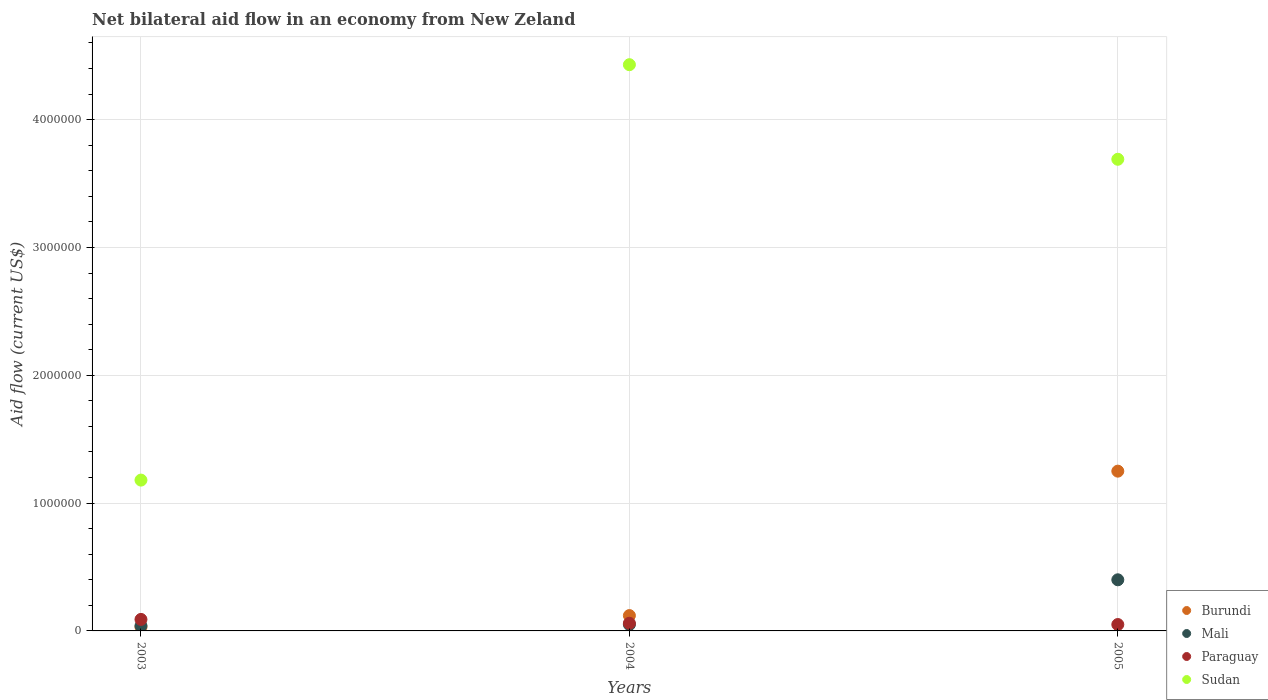Across all years, what is the maximum net bilateral aid flow in Burundi?
Offer a very short reply. 1.25e+06. In which year was the net bilateral aid flow in Burundi maximum?
Ensure brevity in your answer.  2005. What is the total net bilateral aid flow in Burundi in the graph?
Make the answer very short. 1.40e+06. What is the difference between the net bilateral aid flow in Sudan in 2003 and that in 2005?
Your answer should be very brief. -2.51e+06. What is the difference between the net bilateral aid flow in Mali in 2004 and the net bilateral aid flow in Burundi in 2005?
Your response must be concise. -1.20e+06. What is the average net bilateral aid flow in Burundi per year?
Give a very brief answer. 4.67e+05. In the year 2003, what is the difference between the net bilateral aid flow in Sudan and net bilateral aid flow in Paraguay?
Provide a succinct answer. 1.09e+06. What is the ratio of the net bilateral aid flow in Paraguay in 2003 to that in 2005?
Ensure brevity in your answer.  1.8. Is the net bilateral aid flow in Paraguay in 2004 less than that in 2005?
Your answer should be very brief. No. Is the difference between the net bilateral aid flow in Sudan in 2004 and 2005 greater than the difference between the net bilateral aid flow in Paraguay in 2004 and 2005?
Provide a succinct answer. Yes. What is the difference between the highest and the second highest net bilateral aid flow in Burundi?
Keep it short and to the point. 1.13e+06. What is the difference between the highest and the lowest net bilateral aid flow in Sudan?
Make the answer very short. 3.25e+06. In how many years, is the net bilateral aid flow in Burundi greater than the average net bilateral aid flow in Burundi taken over all years?
Give a very brief answer. 1. Is the sum of the net bilateral aid flow in Sudan in 2003 and 2005 greater than the maximum net bilateral aid flow in Mali across all years?
Offer a very short reply. Yes. Is it the case that in every year, the sum of the net bilateral aid flow in Mali and net bilateral aid flow in Paraguay  is greater than the sum of net bilateral aid flow in Sudan and net bilateral aid flow in Burundi?
Offer a very short reply. No. Is it the case that in every year, the sum of the net bilateral aid flow in Sudan and net bilateral aid flow in Burundi  is greater than the net bilateral aid flow in Mali?
Make the answer very short. Yes. Does the net bilateral aid flow in Paraguay monotonically increase over the years?
Provide a short and direct response. No. Is the net bilateral aid flow in Paraguay strictly greater than the net bilateral aid flow in Mali over the years?
Keep it short and to the point. No. How many dotlines are there?
Keep it short and to the point. 4. Are the values on the major ticks of Y-axis written in scientific E-notation?
Your answer should be very brief. No. Does the graph contain any zero values?
Your response must be concise. No. Does the graph contain grids?
Provide a succinct answer. Yes. Where does the legend appear in the graph?
Provide a short and direct response. Bottom right. How many legend labels are there?
Ensure brevity in your answer.  4. How are the legend labels stacked?
Offer a very short reply. Vertical. What is the title of the graph?
Your response must be concise. Net bilateral aid flow in an economy from New Zeland. Does "Latin America(all income levels)" appear as one of the legend labels in the graph?
Your response must be concise. No. What is the label or title of the X-axis?
Your response must be concise. Years. What is the Aid flow (current US$) in Burundi in 2003?
Your response must be concise. 3.00e+04. What is the Aid flow (current US$) of Mali in 2003?
Provide a succinct answer. 4.00e+04. What is the Aid flow (current US$) in Paraguay in 2003?
Provide a short and direct response. 9.00e+04. What is the Aid flow (current US$) of Sudan in 2003?
Keep it short and to the point. 1.18e+06. What is the Aid flow (current US$) of Sudan in 2004?
Offer a very short reply. 4.43e+06. What is the Aid flow (current US$) in Burundi in 2005?
Make the answer very short. 1.25e+06. What is the Aid flow (current US$) of Mali in 2005?
Your answer should be compact. 4.00e+05. What is the Aid flow (current US$) of Paraguay in 2005?
Your answer should be very brief. 5.00e+04. What is the Aid flow (current US$) of Sudan in 2005?
Give a very brief answer. 3.69e+06. Across all years, what is the maximum Aid flow (current US$) in Burundi?
Your answer should be compact. 1.25e+06. Across all years, what is the maximum Aid flow (current US$) of Sudan?
Your answer should be compact. 4.43e+06. Across all years, what is the minimum Aid flow (current US$) of Burundi?
Provide a short and direct response. 3.00e+04. Across all years, what is the minimum Aid flow (current US$) of Paraguay?
Keep it short and to the point. 5.00e+04. Across all years, what is the minimum Aid flow (current US$) in Sudan?
Ensure brevity in your answer.  1.18e+06. What is the total Aid flow (current US$) of Burundi in the graph?
Your answer should be very brief. 1.40e+06. What is the total Aid flow (current US$) in Mali in the graph?
Provide a short and direct response. 4.90e+05. What is the total Aid flow (current US$) of Sudan in the graph?
Provide a succinct answer. 9.30e+06. What is the difference between the Aid flow (current US$) of Burundi in 2003 and that in 2004?
Provide a short and direct response. -9.00e+04. What is the difference between the Aid flow (current US$) in Paraguay in 2003 and that in 2004?
Your response must be concise. 3.00e+04. What is the difference between the Aid flow (current US$) of Sudan in 2003 and that in 2004?
Provide a short and direct response. -3.25e+06. What is the difference between the Aid flow (current US$) in Burundi in 2003 and that in 2005?
Your response must be concise. -1.22e+06. What is the difference between the Aid flow (current US$) in Mali in 2003 and that in 2005?
Make the answer very short. -3.60e+05. What is the difference between the Aid flow (current US$) in Sudan in 2003 and that in 2005?
Provide a succinct answer. -2.51e+06. What is the difference between the Aid flow (current US$) in Burundi in 2004 and that in 2005?
Offer a terse response. -1.13e+06. What is the difference between the Aid flow (current US$) in Mali in 2004 and that in 2005?
Your answer should be compact. -3.50e+05. What is the difference between the Aid flow (current US$) in Sudan in 2004 and that in 2005?
Give a very brief answer. 7.40e+05. What is the difference between the Aid flow (current US$) in Burundi in 2003 and the Aid flow (current US$) in Mali in 2004?
Provide a succinct answer. -2.00e+04. What is the difference between the Aid flow (current US$) in Burundi in 2003 and the Aid flow (current US$) in Sudan in 2004?
Offer a very short reply. -4.40e+06. What is the difference between the Aid flow (current US$) in Mali in 2003 and the Aid flow (current US$) in Paraguay in 2004?
Provide a succinct answer. -2.00e+04. What is the difference between the Aid flow (current US$) of Mali in 2003 and the Aid flow (current US$) of Sudan in 2004?
Give a very brief answer. -4.39e+06. What is the difference between the Aid flow (current US$) of Paraguay in 2003 and the Aid flow (current US$) of Sudan in 2004?
Your answer should be very brief. -4.34e+06. What is the difference between the Aid flow (current US$) in Burundi in 2003 and the Aid flow (current US$) in Mali in 2005?
Give a very brief answer. -3.70e+05. What is the difference between the Aid flow (current US$) in Burundi in 2003 and the Aid flow (current US$) in Sudan in 2005?
Your answer should be compact. -3.66e+06. What is the difference between the Aid flow (current US$) in Mali in 2003 and the Aid flow (current US$) in Sudan in 2005?
Give a very brief answer. -3.65e+06. What is the difference between the Aid flow (current US$) in Paraguay in 2003 and the Aid flow (current US$) in Sudan in 2005?
Your answer should be compact. -3.60e+06. What is the difference between the Aid flow (current US$) of Burundi in 2004 and the Aid flow (current US$) of Mali in 2005?
Ensure brevity in your answer.  -2.80e+05. What is the difference between the Aid flow (current US$) in Burundi in 2004 and the Aid flow (current US$) in Sudan in 2005?
Make the answer very short. -3.57e+06. What is the difference between the Aid flow (current US$) in Mali in 2004 and the Aid flow (current US$) in Paraguay in 2005?
Provide a succinct answer. 0. What is the difference between the Aid flow (current US$) in Mali in 2004 and the Aid flow (current US$) in Sudan in 2005?
Provide a succinct answer. -3.64e+06. What is the difference between the Aid flow (current US$) of Paraguay in 2004 and the Aid flow (current US$) of Sudan in 2005?
Make the answer very short. -3.63e+06. What is the average Aid flow (current US$) in Burundi per year?
Your response must be concise. 4.67e+05. What is the average Aid flow (current US$) of Mali per year?
Ensure brevity in your answer.  1.63e+05. What is the average Aid flow (current US$) in Paraguay per year?
Ensure brevity in your answer.  6.67e+04. What is the average Aid flow (current US$) in Sudan per year?
Ensure brevity in your answer.  3.10e+06. In the year 2003, what is the difference between the Aid flow (current US$) in Burundi and Aid flow (current US$) in Mali?
Provide a short and direct response. -10000. In the year 2003, what is the difference between the Aid flow (current US$) of Burundi and Aid flow (current US$) of Paraguay?
Your answer should be very brief. -6.00e+04. In the year 2003, what is the difference between the Aid flow (current US$) in Burundi and Aid flow (current US$) in Sudan?
Provide a short and direct response. -1.15e+06. In the year 2003, what is the difference between the Aid flow (current US$) in Mali and Aid flow (current US$) in Sudan?
Your answer should be very brief. -1.14e+06. In the year 2003, what is the difference between the Aid flow (current US$) of Paraguay and Aid flow (current US$) of Sudan?
Keep it short and to the point. -1.09e+06. In the year 2004, what is the difference between the Aid flow (current US$) in Burundi and Aid flow (current US$) in Sudan?
Offer a terse response. -4.31e+06. In the year 2004, what is the difference between the Aid flow (current US$) of Mali and Aid flow (current US$) of Sudan?
Your answer should be very brief. -4.38e+06. In the year 2004, what is the difference between the Aid flow (current US$) in Paraguay and Aid flow (current US$) in Sudan?
Make the answer very short. -4.37e+06. In the year 2005, what is the difference between the Aid flow (current US$) in Burundi and Aid flow (current US$) in Mali?
Offer a terse response. 8.50e+05. In the year 2005, what is the difference between the Aid flow (current US$) of Burundi and Aid flow (current US$) of Paraguay?
Provide a succinct answer. 1.20e+06. In the year 2005, what is the difference between the Aid flow (current US$) in Burundi and Aid flow (current US$) in Sudan?
Keep it short and to the point. -2.44e+06. In the year 2005, what is the difference between the Aid flow (current US$) of Mali and Aid flow (current US$) of Paraguay?
Your response must be concise. 3.50e+05. In the year 2005, what is the difference between the Aid flow (current US$) of Mali and Aid flow (current US$) of Sudan?
Your response must be concise. -3.29e+06. In the year 2005, what is the difference between the Aid flow (current US$) in Paraguay and Aid flow (current US$) in Sudan?
Your answer should be very brief. -3.64e+06. What is the ratio of the Aid flow (current US$) of Burundi in 2003 to that in 2004?
Give a very brief answer. 0.25. What is the ratio of the Aid flow (current US$) in Mali in 2003 to that in 2004?
Keep it short and to the point. 0.8. What is the ratio of the Aid flow (current US$) of Sudan in 2003 to that in 2004?
Your response must be concise. 0.27. What is the ratio of the Aid flow (current US$) of Burundi in 2003 to that in 2005?
Your answer should be compact. 0.02. What is the ratio of the Aid flow (current US$) of Paraguay in 2003 to that in 2005?
Keep it short and to the point. 1.8. What is the ratio of the Aid flow (current US$) of Sudan in 2003 to that in 2005?
Your response must be concise. 0.32. What is the ratio of the Aid flow (current US$) in Burundi in 2004 to that in 2005?
Offer a very short reply. 0.1. What is the ratio of the Aid flow (current US$) of Mali in 2004 to that in 2005?
Ensure brevity in your answer.  0.12. What is the ratio of the Aid flow (current US$) of Paraguay in 2004 to that in 2005?
Your answer should be compact. 1.2. What is the ratio of the Aid flow (current US$) of Sudan in 2004 to that in 2005?
Make the answer very short. 1.2. What is the difference between the highest and the second highest Aid flow (current US$) of Burundi?
Offer a very short reply. 1.13e+06. What is the difference between the highest and the second highest Aid flow (current US$) in Mali?
Give a very brief answer. 3.50e+05. What is the difference between the highest and the second highest Aid flow (current US$) of Paraguay?
Keep it short and to the point. 3.00e+04. What is the difference between the highest and the second highest Aid flow (current US$) in Sudan?
Ensure brevity in your answer.  7.40e+05. What is the difference between the highest and the lowest Aid flow (current US$) in Burundi?
Your answer should be compact. 1.22e+06. What is the difference between the highest and the lowest Aid flow (current US$) in Paraguay?
Your answer should be very brief. 4.00e+04. What is the difference between the highest and the lowest Aid flow (current US$) in Sudan?
Provide a short and direct response. 3.25e+06. 